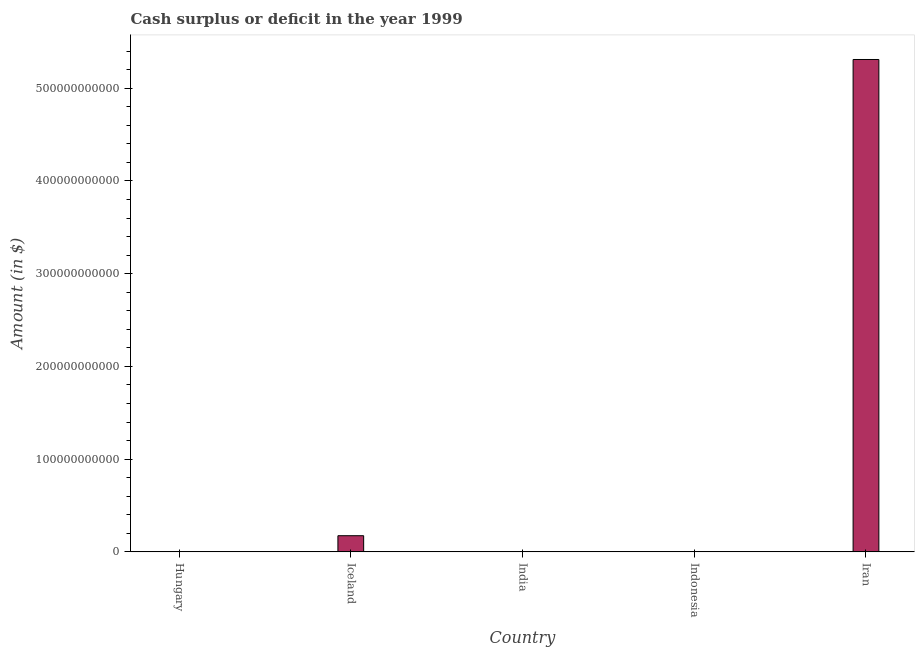Does the graph contain any zero values?
Your answer should be very brief. Yes. Does the graph contain grids?
Provide a short and direct response. No. What is the title of the graph?
Offer a terse response. Cash surplus or deficit in the year 1999. What is the label or title of the Y-axis?
Give a very brief answer. Amount (in $). Across all countries, what is the maximum cash surplus or deficit?
Ensure brevity in your answer.  5.31e+11. Across all countries, what is the minimum cash surplus or deficit?
Provide a succinct answer. 0. In which country was the cash surplus or deficit maximum?
Keep it short and to the point. Iran. What is the sum of the cash surplus or deficit?
Make the answer very short. 5.48e+11. What is the average cash surplus or deficit per country?
Provide a short and direct response. 1.10e+11. What is the median cash surplus or deficit?
Your answer should be very brief. 0. In how many countries, is the cash surplus or deficit greater than 200000000000 $?
Keep it short and to the point. 1. What is the ratio of the cash surplus or deficit in Iceland to that in Iran?
Offer a very short reply. 0.03. Is the difference between the cash surplus or deficit in Iceland and Iran greater than the difference between any two countries?
Ensure brevity in your answer.  No. What is the difference between the highest and the lowest cash surplus or deficit?
Provide a succinct answer. 5.31e+11. In how many countries, is the cash surplus or deficit greater than the average cash surplus or deficit taken over all countries?
Offer a terse response. 1. What is the difference between two consecutive major ticks on the Y-axis?
Make the answer very short. 1.00e+11. Are the values on the major ticks of Y-axis written in scientific E-notation?
Offer a terse response. No. What is the Amount (in $) of Hungary?
Keep it short and to the point. 0. What is the Amount (in $) in Iceland?
Your answer should be very brief. 1.74e+1. What is the Amount (in $) of Iran?
Provide a short and direct response. 5.31e+11. What is the difference between the Amount (in $) in Iceland and Iran?
Give a very brief answer. -5.14e+11. What is the ratio of the Amount (in $) in Iceland to that in Iran?
Make the answer very short. 0.03. 